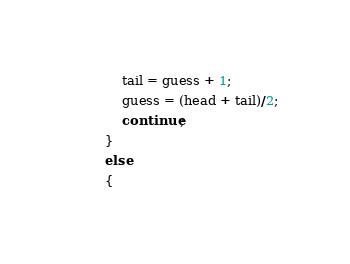Convert code to text. <code><loc_0><loc_0><loc_500><loc_500><_C_>            tail = guess + 1;
            guess = (head + tail)/2;
            continue;
        }
        else
        {</code> 